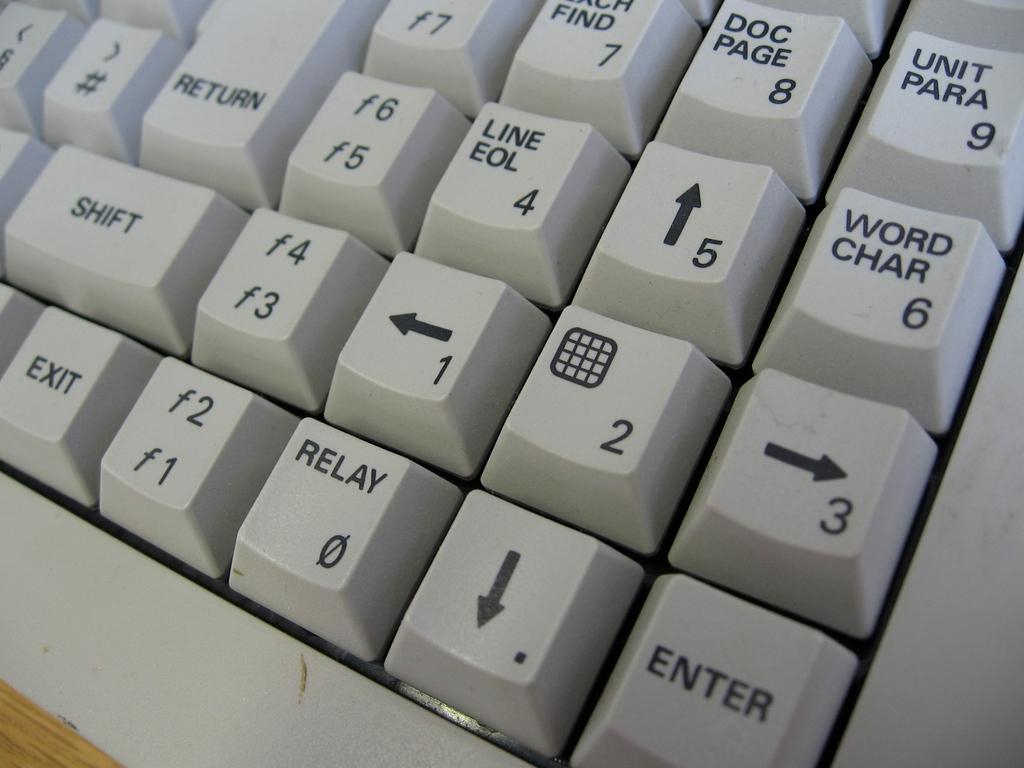Is there an enter key shown?
Offer a very short reply. Yes. What is the key in the top right corner?
Make the answer very short. Unit para 9. 